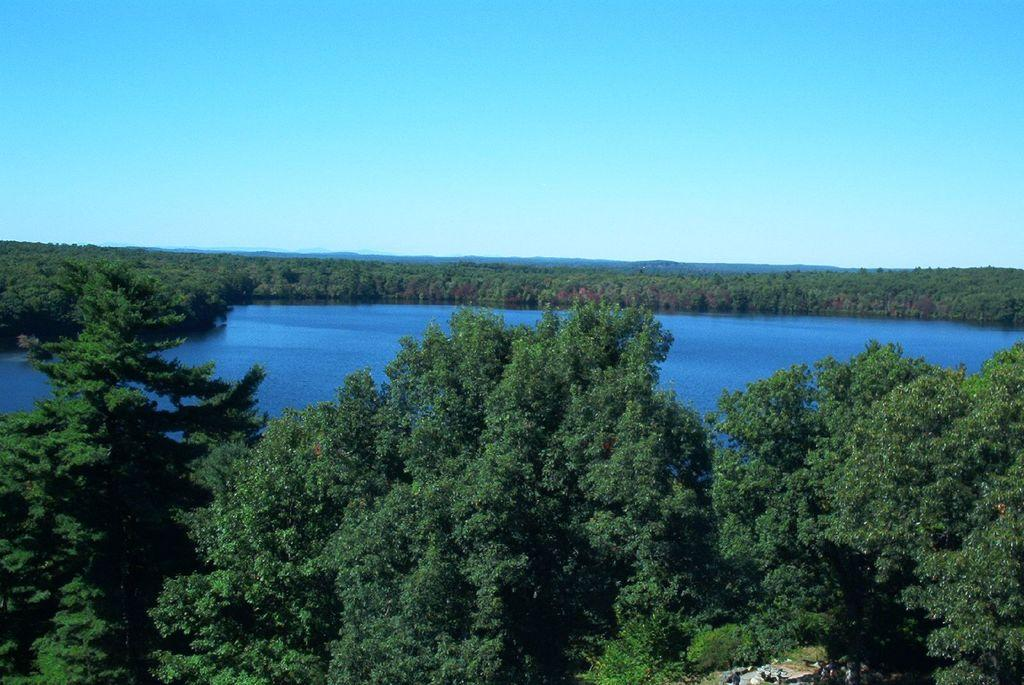What type of natural environment is depicted in the image? The image features many trees, which suggests a forest or wooded area. What else can be seen in the image besides trees? There is water visible in the image. What is visible at the top of the image? The sky is visible at the top of the image. What type of paper can be seen floating on the water in the image? There is no paper visible in the image; only trees, water, and sky are present. 